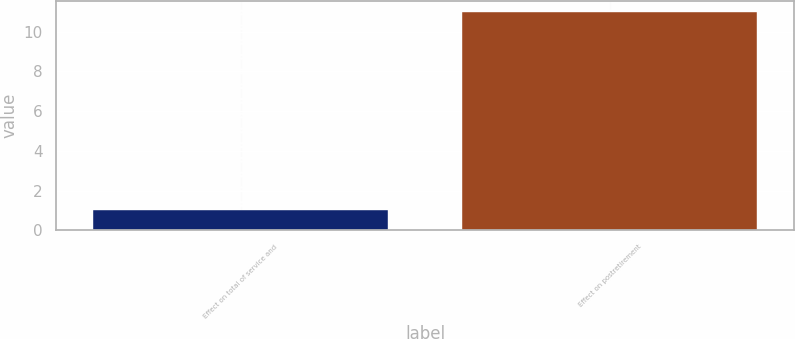Convert chart. <chart><loc_0><loc_0><loc_500><loc_500><bar_chart><fcel>Effect on total of service and<fcel>Effect on postretirement<nl><fcel>1<fcel>11<nl></chart> 